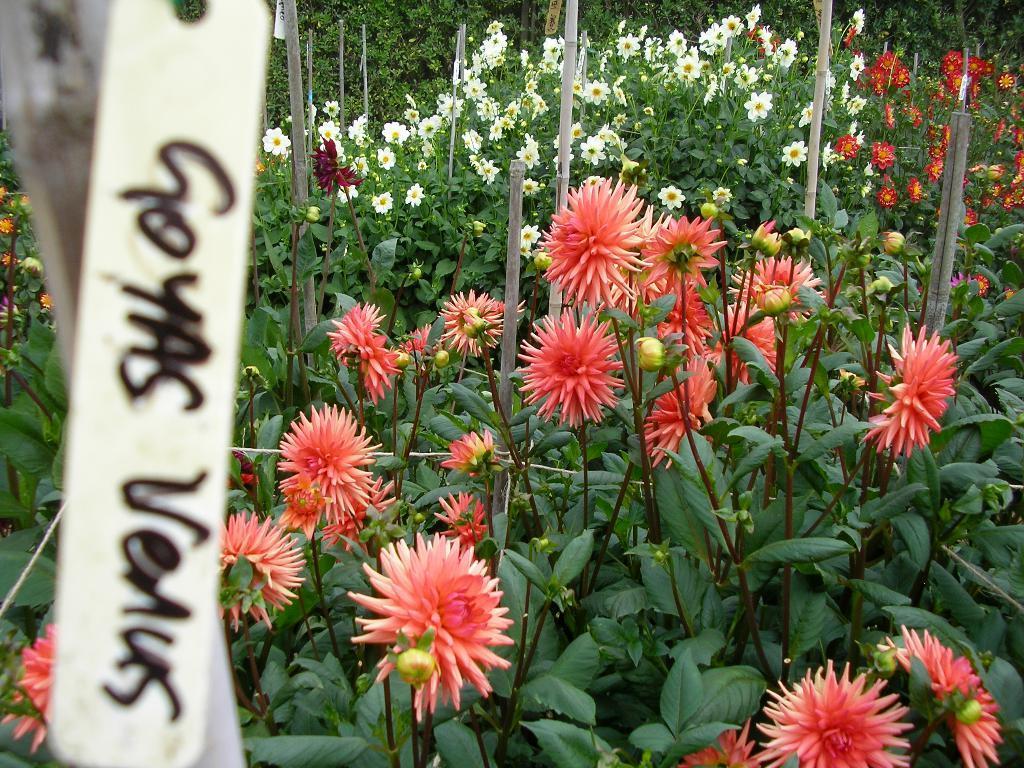How would you summarize this image in a sentence or two? In the foreground of this image, on the left, there are few tags and text is on it. In the background, there are flowers to the plants and we can also see few sticks. 